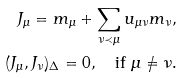Convert formula to latex. <formula><loc_0><loc_0><loc_500><loc_500>J _ { \mu } = m _ { \mu } + \sum _ { \nu \prec \mu } u _ { \mu \nu } m _ { \nu } , \\ ( J _ { \mu } , J _ { \nu } ) _ { \Delta } = 0 , \quad \text {if } \mu \neq \nu .</formula> 